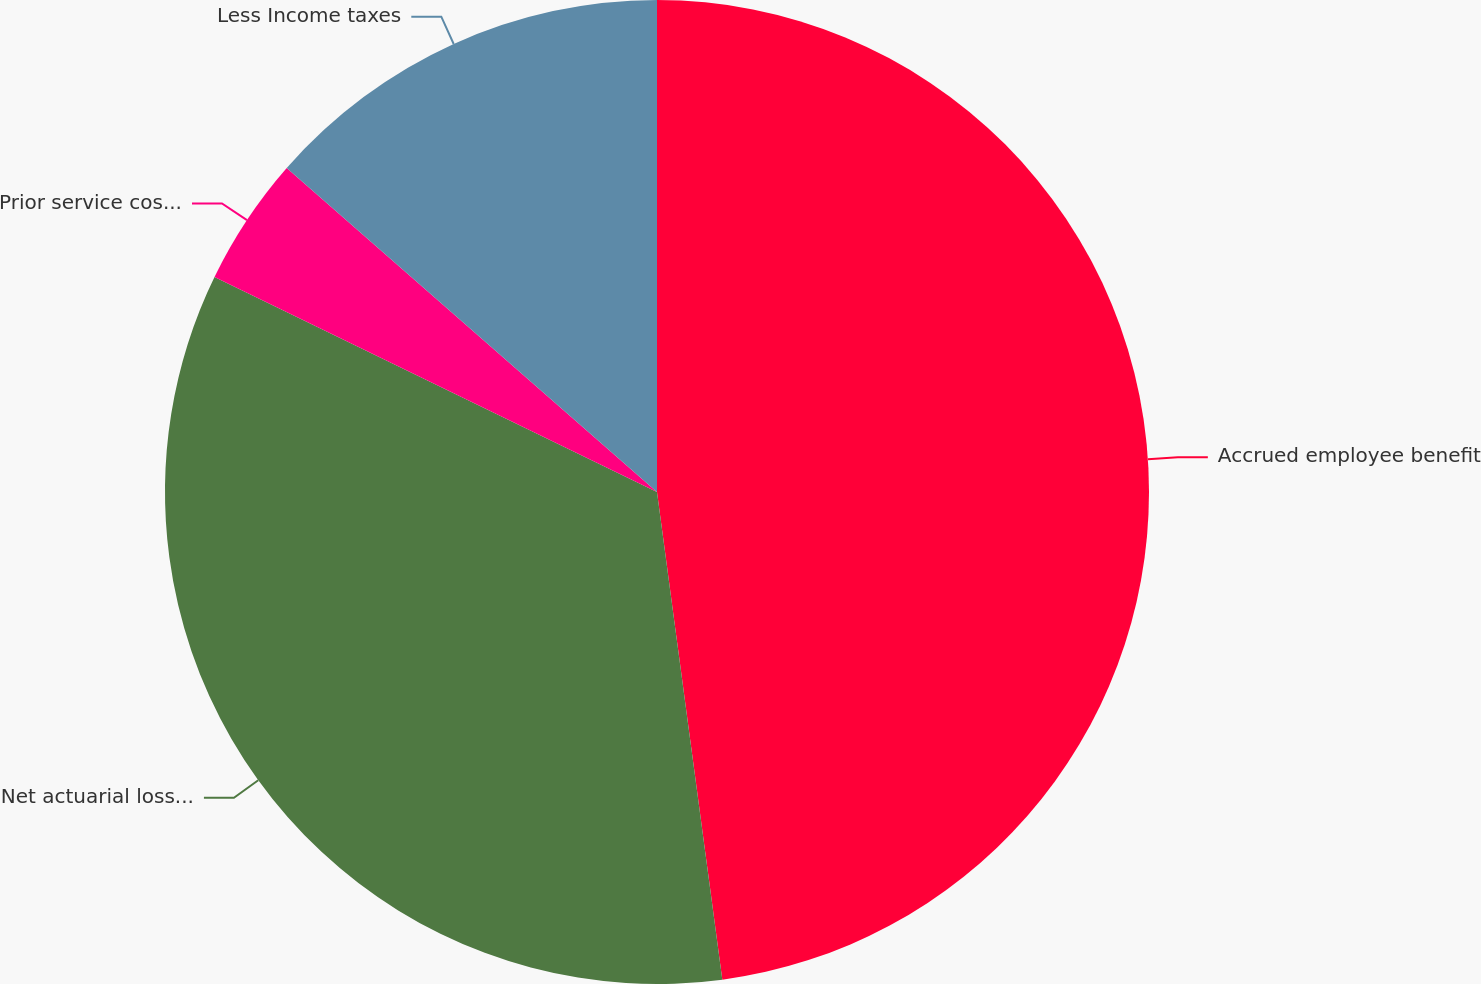Convert chart to OTSL. <chart><loc_0><loc_0><loc_500><loc_500><pie_chart><fcel>Accrued employee benefit<fcel>Net actuarial loss (gain)<fcel>Prior service cost (credit)<fcel>Less Income taxes<nl><fcel>47.88%<fcel>34.32%<fcel>4.24%<fcel>13.56%<nl></chart> 